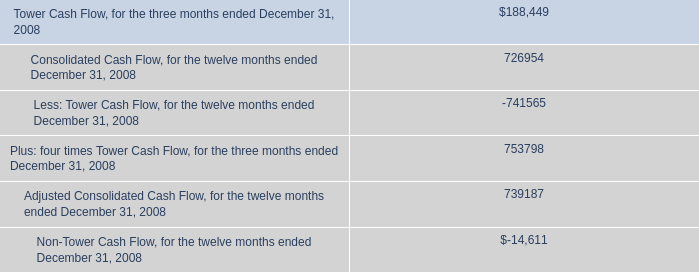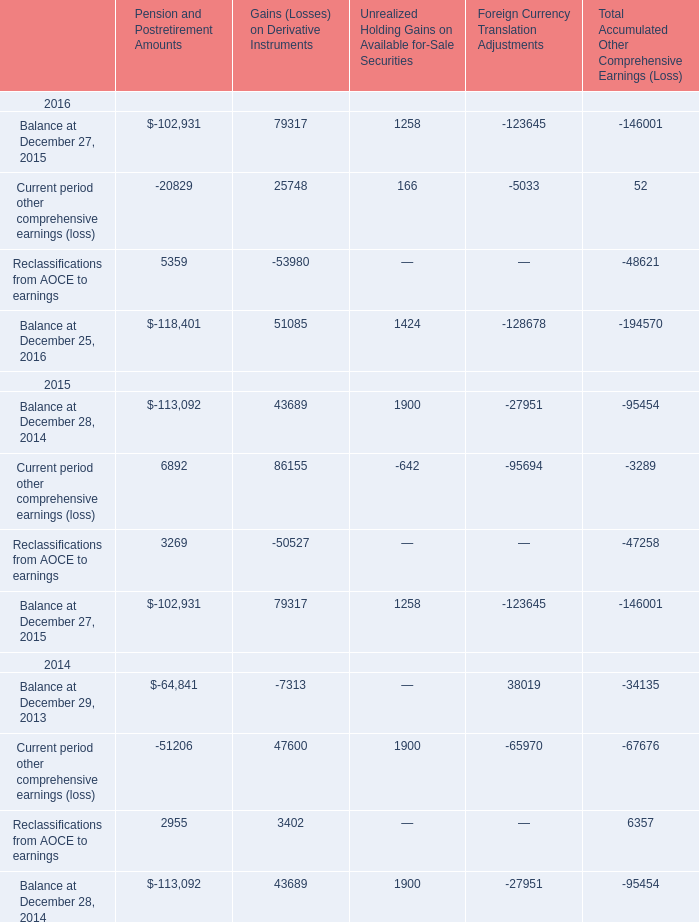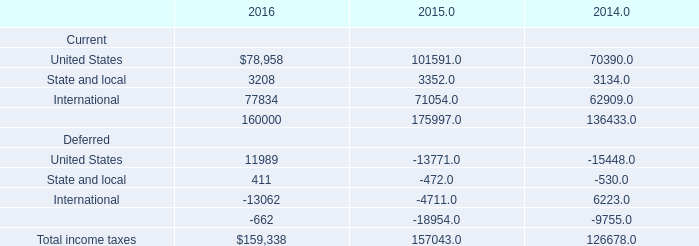In the year with largest amount of Current period other comprehensive earnings (loss) in Gains (Losses) on Derivative Instruments, what's the sum of Reclassifications from AOCE to earnings? 
Computations: (3269 - 50527)
Answer: -47258.0. 